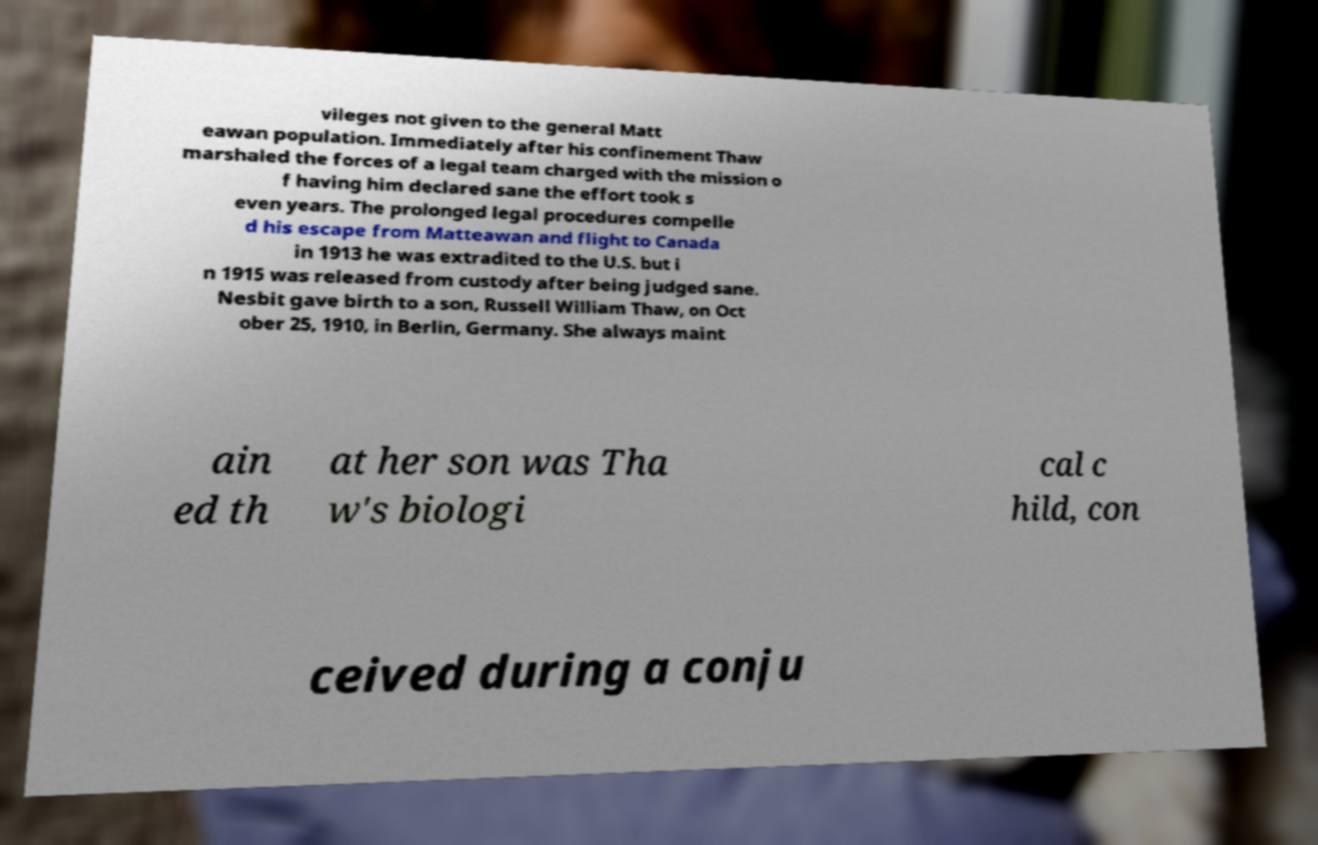Can you accurately transcribe the text from the provided image for me? vileges not given to the general Matt eawan population. Immediately after his confinement Thaw marshaled the forces of a legal team charged with the mission o f having him declared sane the effort took s even years. The prolonged legal procedures compelle d his escape from Matteawan and flight to Canada in 1913 he was extradited to the U.S. but i n 1915 was released from custody after being judged sane. Nesbit gave birth to a son, Russell William Thaw, on Oct ober 25, 1910, in Berlin, Germany. She always maint ain ed th at her son was Tha w's biologi cal c hild, con ceived during a conju 